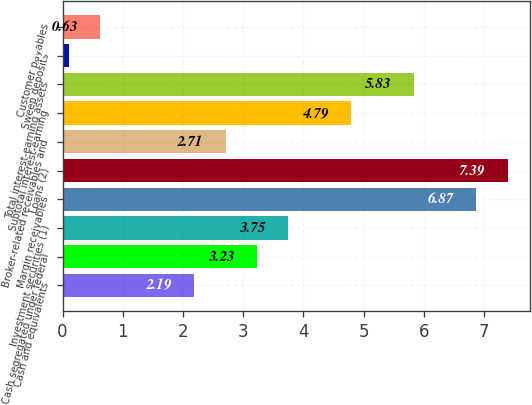<chart> <loc_0><loc_0><loc_500><loc_500><bar_chart><fcel>Cash and equivalents<fcel>Cash segregated under federal<fcel>Investment securities (1)<fcel>Margin receivables<fcel>Loans (2)<fcel>Broker-related receivables and<fcel>Subtotal interest-earning<fcel>Total interest-earning assets<fcel>Sweep deposits<fcel>Customer payables<nl><fcel>2.19<fcel>3.23<fcel>3.75<fcel>6.87<fcel>7.39<fcel>2.71<fcel>4.79<fcel>5.83<fcel>0.11<fcel>0.63<nl></chart> 